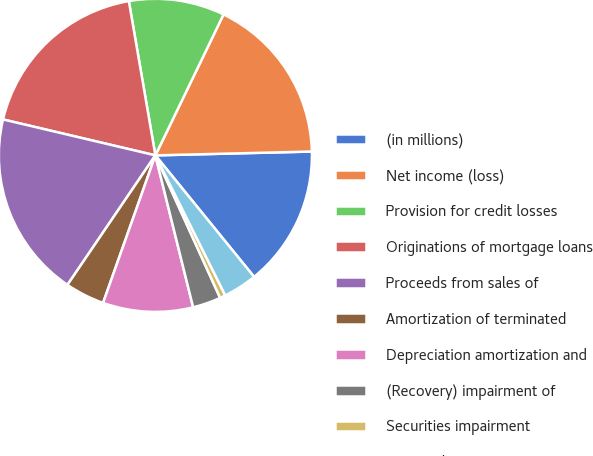<chart> <loc_0><loc_0><loc_500><loc_500><pie_chart><fcel>(in millions)<fcel>Net income (loss)<fcel>Provision for credit losses<fcel>Originations of mortgage loans<fcel>Proceeds from sales of<fcel>Amortization of terminated<fcel>Depreciation amortization and<fcel>(Recovery) impairment of<fcel>Securities impairment<fcel>Deferred income taxes<nl><fcel>14.53%<fcel>17.44%<fcel>9.88%<fcel>18.6%<fcel>19.19%<fcel>4.07%<fcel>9.3%<fcel>2.91%<fcel>0.58%<fcel>3.49%<nl></chart> 